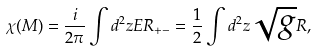<formula> <loc_0><loc_0><loc_500><loc_500>\chi ( M ) = \frac { i } { 2 \pi } \int d ^ { 2 } z E R _ { + - } = \frac { 1 } { 2 } \int d ^ { 2 } z \sqrt { g } R ,</formula> 